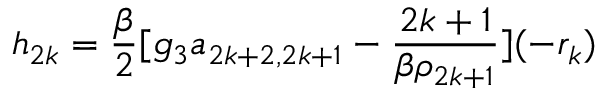Convert formula to latex. <formula><loc_0><loc_0><loc_500><loc_500>h _ { 2 k } = \frac { \beta } { 2 } [ g _ { 3 } a _ { 2 k + 2 , 2 k + 1 } - \frac { 2 k + 1 } { \beta \rho _ { 2 k + 1 } } ] ( - r _ { k } )</formula> 